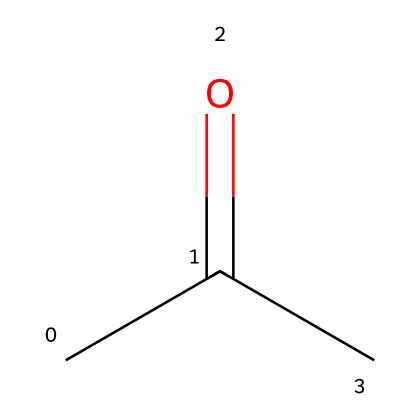What is the molecular formula of acetone? The chemical structure shows three carbon atoms (C), six hydrogen atoms (H), and one oxygen atom (O). Thus, the molecular formula can be deduced as C3H6O.
Answer: C3H6O How many carbon atoms are in acetone? By examining the structure, there are three carbon atoms visible in the chain of the acetone molecule.
Answer: 3 What type of functional group is present in acetone? The structure includes a carbonyl group (C=O) attached to a carbon atom, which is characteristic of ketones. Thus, the functional group in acetone is a ketone.
Answer: ketone Is acetone polar or non-polar? The presence of a polar carbonyl group (C=O) in the molecule contributes to its polarity, while the carbon chain also affects overall polarity. Hence, acetone is polar.
Answer: polar What is the approximate boiling point of acetone? Acetone typically boils around 56 degrees Celsius under atmospheric pressure, based on its chemical properties.
Answer: 56 Why is acetone classified as a non-electrolyte? As a non-electrolyte, acetone does not dissociate into ions in solution, which can be attributed to its covalent nature and lack of ionic structure.
Answer: does not dissociate into ions 